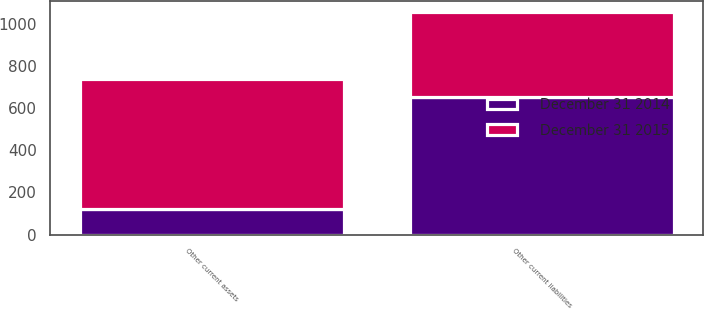Convert chart. <chart><loc_0><loc_0><loc_500><loc_500><stacked_bar_chart><ecel><fcel>Other current assets<fcel>Other current liabilities<nl><fcel>December 31 2015<fcel>616<fcel>402<nl><fcel>December 31 2014<fcel>123<fcel>651<nl></chart> 